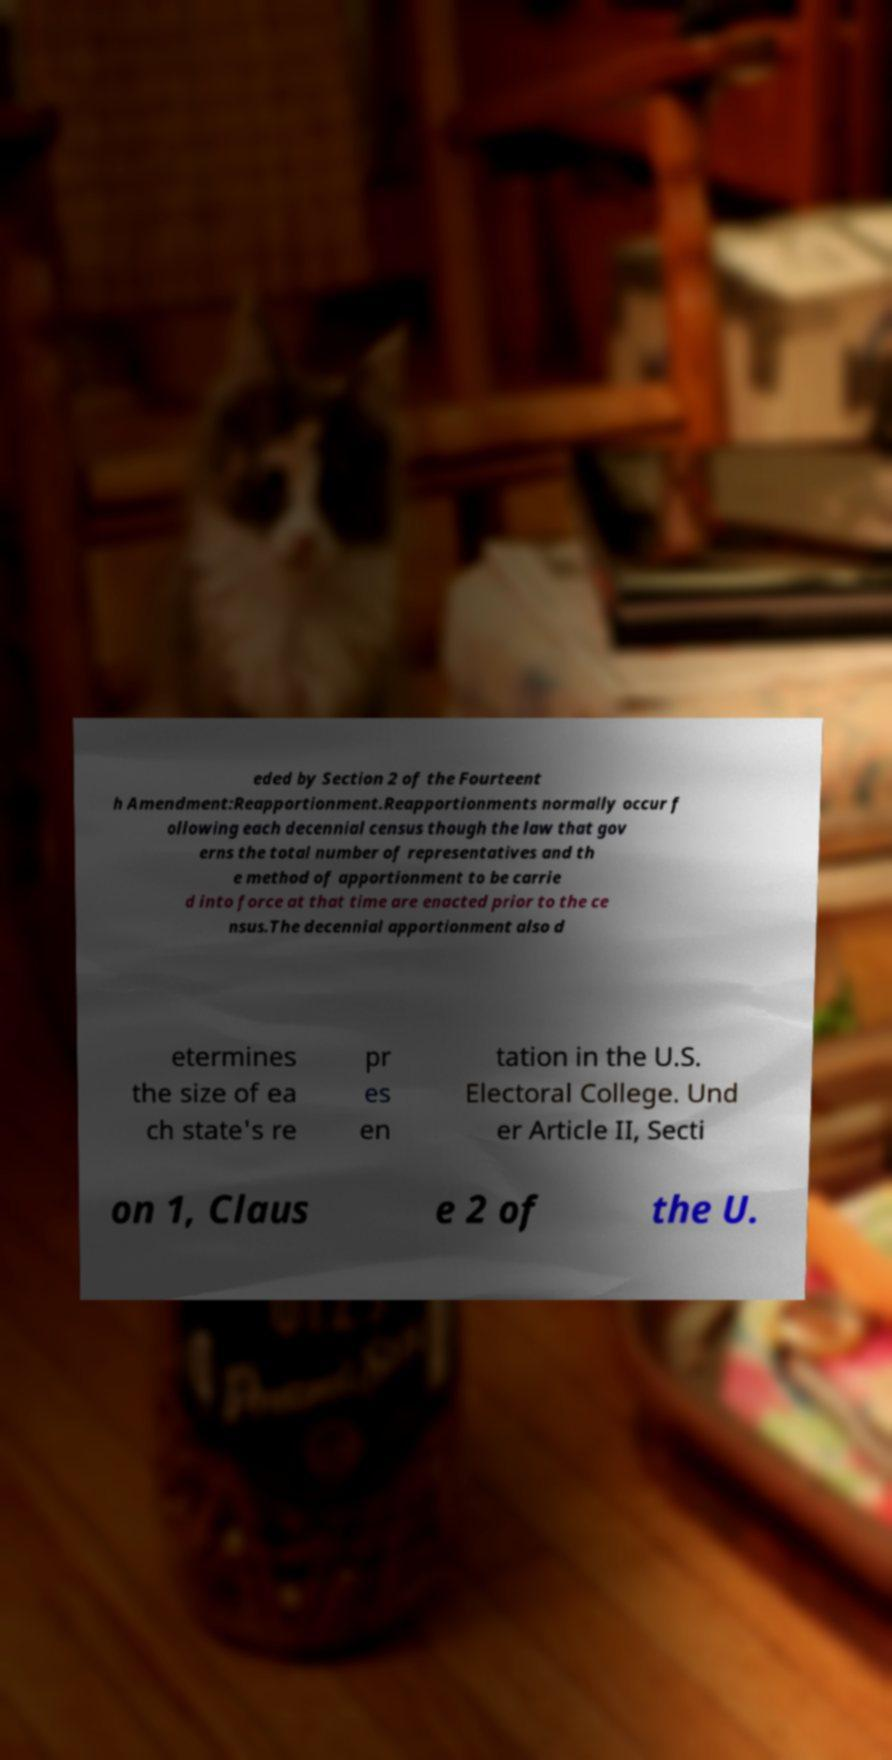There's text embedded in this image that I need extracted. Can you transcribe it verbatim? eded by Section 2 of the Fourteent h Amendment:Reapportionment.Reapportionments normally occur f ollowing each decennial census though the law that gov erns the total number of representatives and th e method of apportionment to be carrie d into force at that time are enacted prior to the ce nsus.The decennial apportionment also d etermines the size of ea ch state's re pr es en tation in the U.S. Electoral College. Und er Article II, Secti on 1, Claus e 2 of the U. 